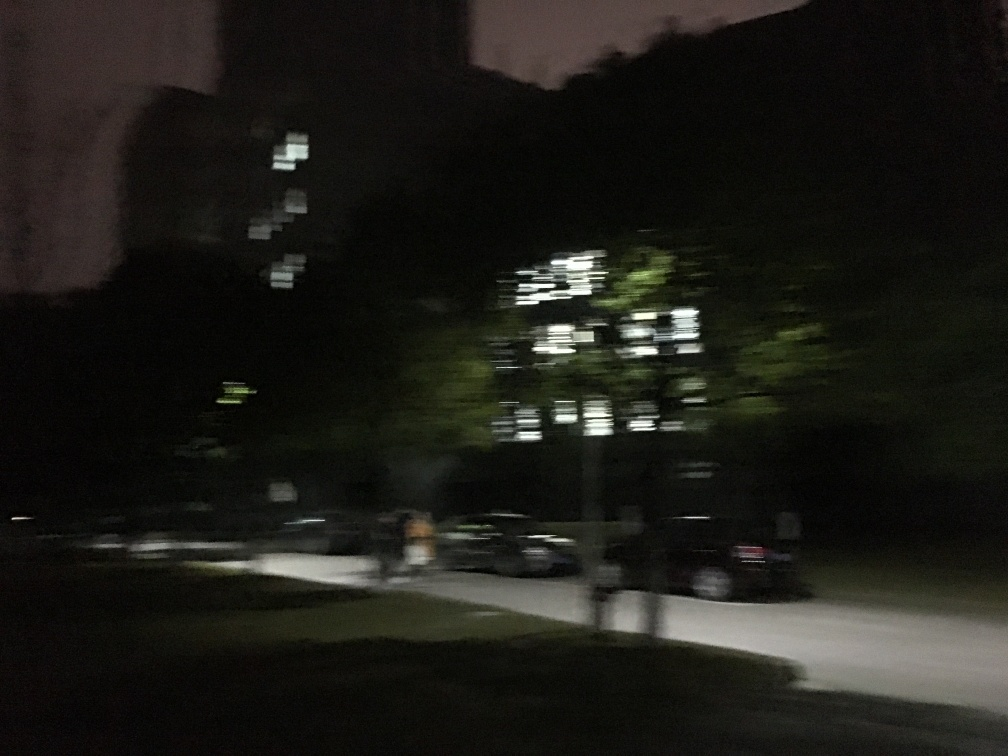Is the image properly exposed? Based on the analysis of the image, it appears that the exposure settings were not optimal, resulting in a photograph that displays areas that are underexposed. This has caused a loss of detail in the darker regions of the image, particularly noticeable in the building's façade and the surrounding foliage. To improve this image, adjusting the exposure to allow more light to reach the camera sensor would enhance the clarity and detail of the scene. 